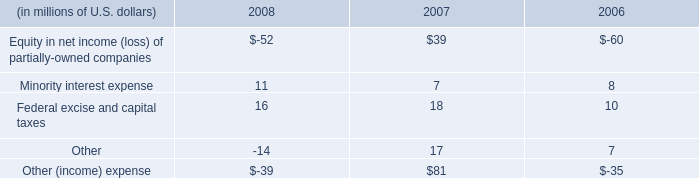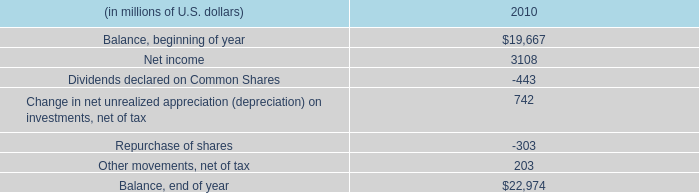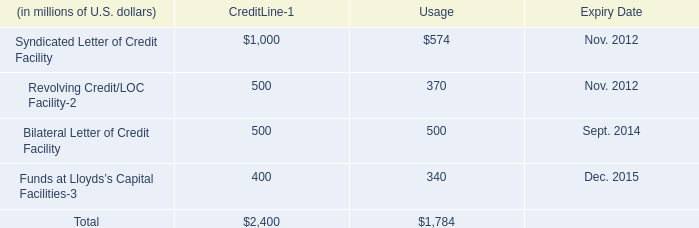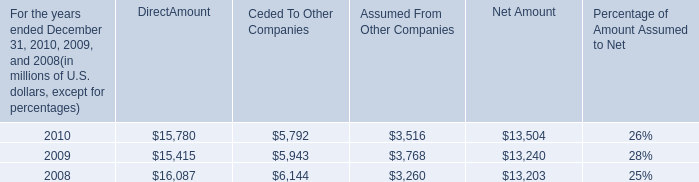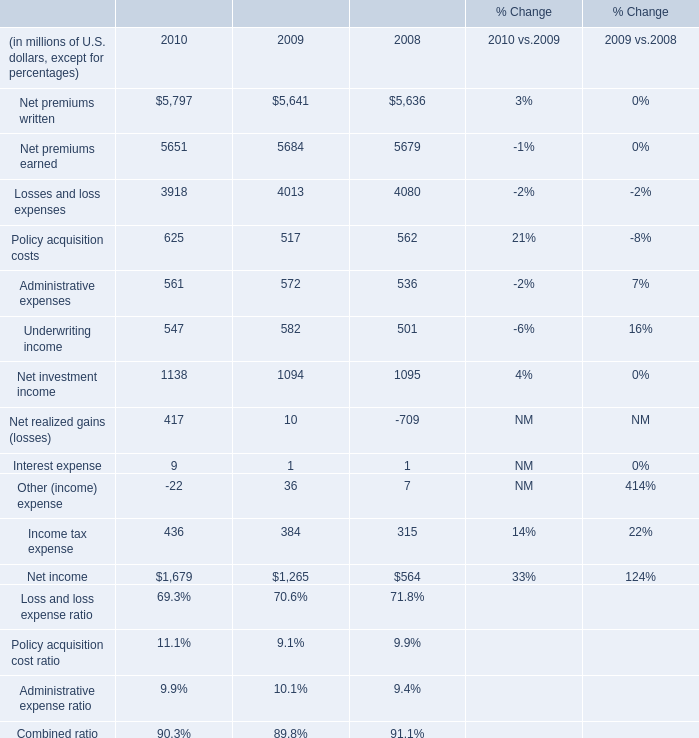what was the percent of the change in the shareholders 2019 equity in 2010 
Computations: ((22974 - 19667) / 19667)
Answer: 0.16815. 